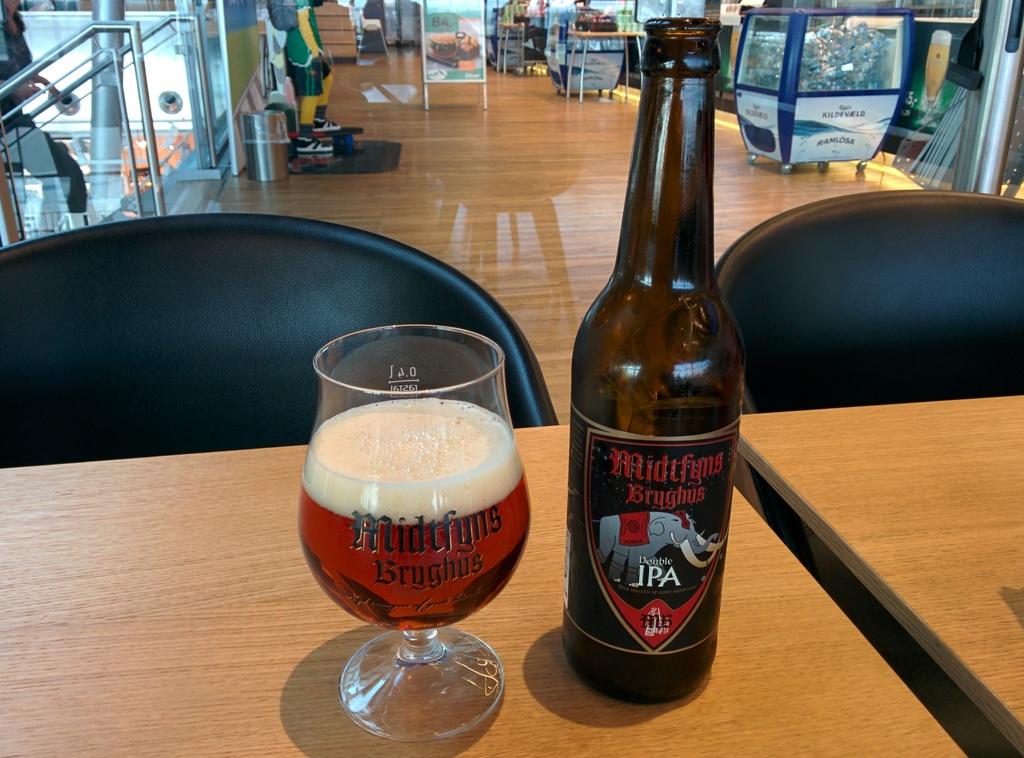What type of drink is this?
Give a very brief answer. Ipa. 